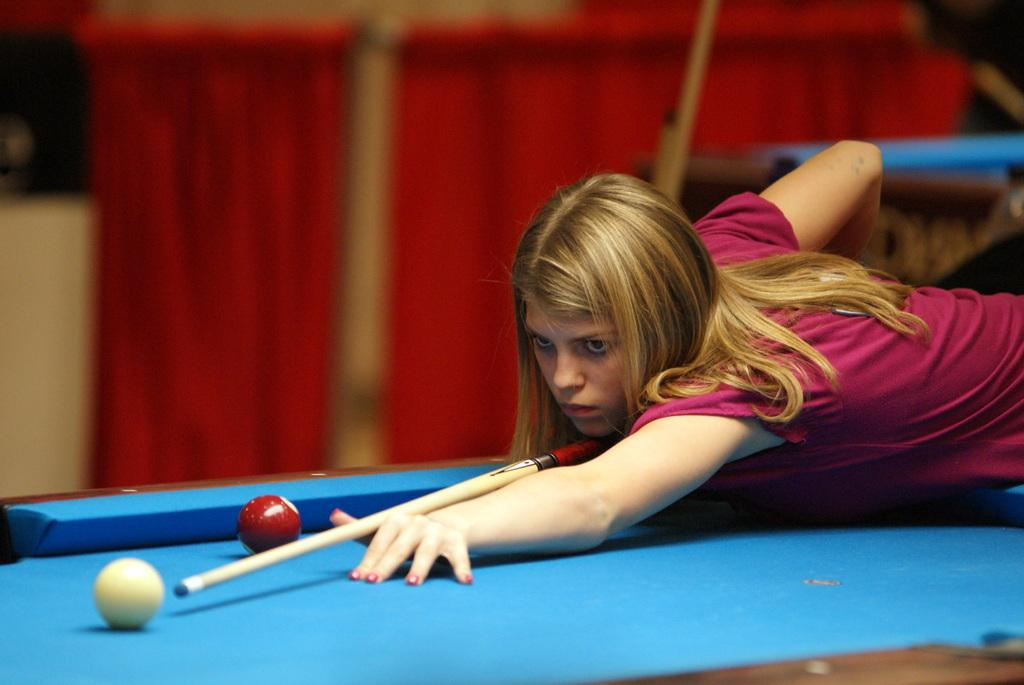Who is present in the image? There is a woman in the image. What is the woman holding in the image? The woman is holding a stick. What is the woman looking at in the image? The woman is looking at a ball. What type of table is visible in the image? There are balls on a snooker table in the image. Can you describe the background of the image? The background of the image is blurry, and there is a red curtain present. What year is depicted in the image? There is no indication of a specific year in the image. What type of heart can be seen in the image? There is no heart present in the image. 